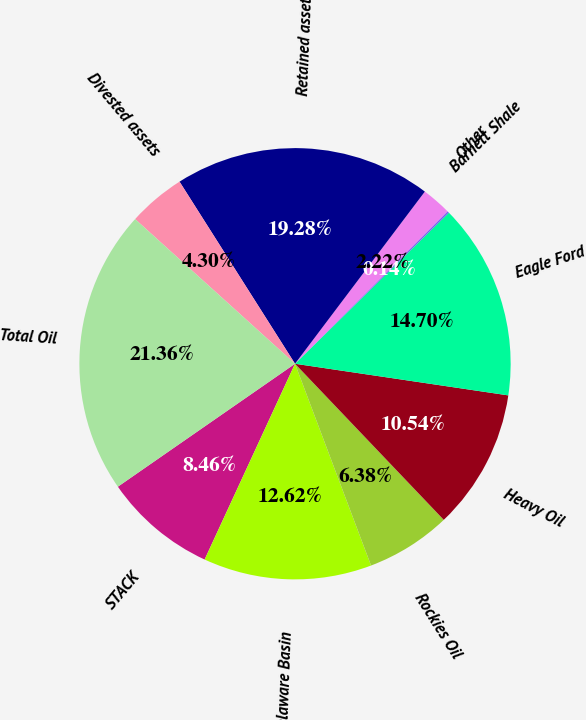<chart> <loc_0><loc_0><loc_500><loc_500><pie_chart><fcel>STACK<fcel>Delaware Basin<fcel>Rockies Oil<fcel>Heavy Oil<fcel>Eagle Ford<fcel>Barnett Shale<fcel>Other<fcel>Retained assets<fcel>Divested assets<fcel>Total Oil<nl><fcel>8.46%<fcel>12.62%<fcel>6.38%<fcel>10.54%<fcel>14.7%<fcel>0.14%<fcel>2.22%<fcel>19.28%<fcel>4.3%<fcel>21.36%<nl></chart> 